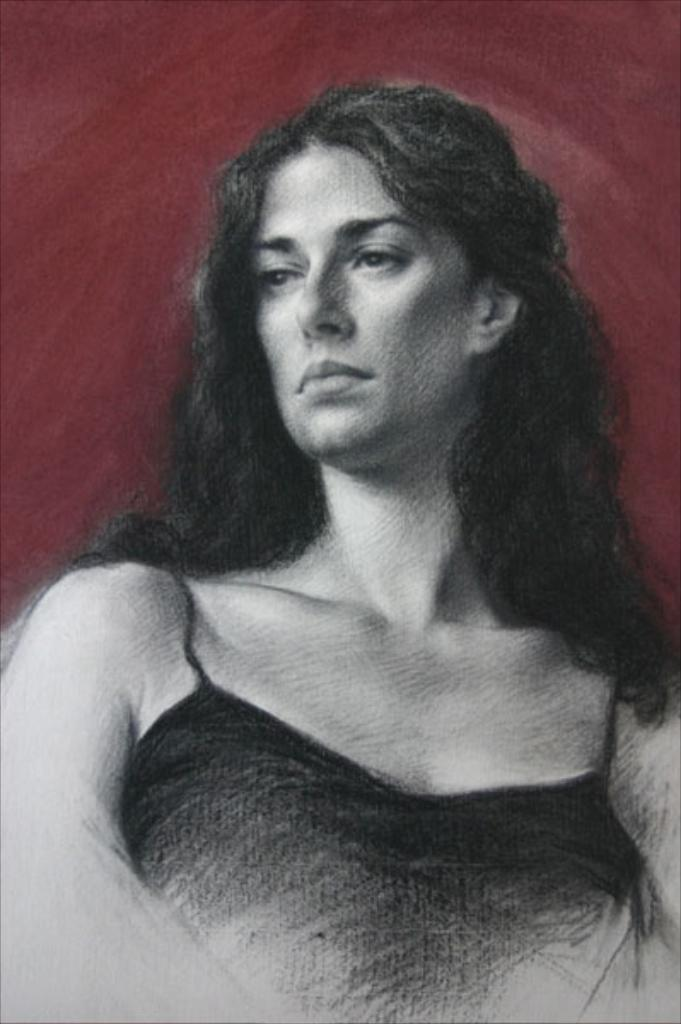What type of image is depicted in the picture? The image is a sketch. What is the subject of the sketch? The sketch is of a woman. What color is the background of the sketch? The background of the sketch is red. What type of frame is around the sketch in the image? There is no frame visible in the image; it is a sketch of a woman with a red background. 